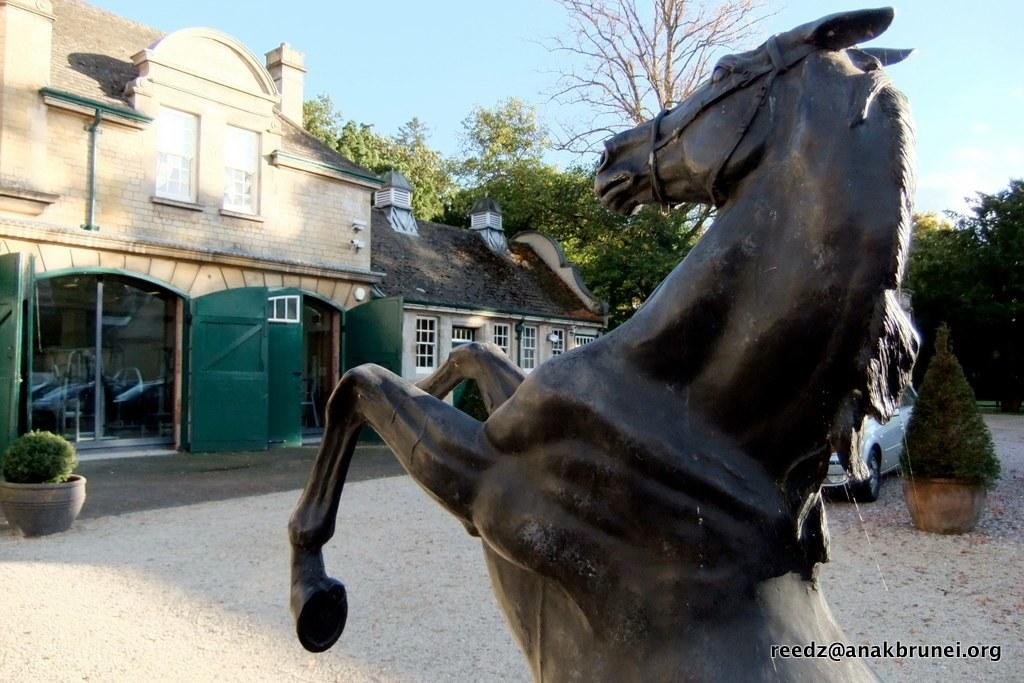What is the main subject in the image? There is a statue in the image. What else can be seen in the image besides the statue? There is a motor vehicle, houseplants, a building, windows, chimneys, trees, and the sky visible in the image. Can you describe the building in the image? The building has windows and chimneys. What is visible in the sky in the image? The sky is visible in the image, and there are clouds in the sky. What type of teeth can be seen on the statue in the image? There are no teeth visible on the statue in the image. What is the rake being used for in the image? There is no rake present in the image. 